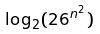Convert formula to latex. <formula><loc_0><loc_0><loc_500><loc_500>\log _ { 2 } ( 2 6 ^ { n ^ { 2 } } )</formula> 